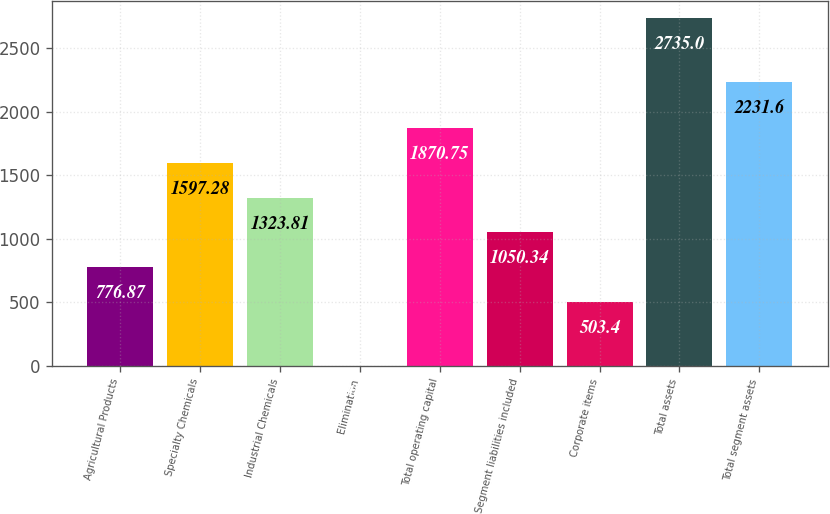Convert chart. <chart><loc_0><loc_0><loc_500><loc_500><bar_chart><fcel>Agricultural Products<fcel>Specialty Chemicals<fcel>Industrial Chemicals<fcel>Elimination<fcel>Total operating capital<fcel>Segment liabilities included<fcel>Corporate items<fcel>Total assets<fcel>Total segment assets<nl><fcel>776.87<fcel>1597.28<fcel>1323.81<fcel>0.3<fcel>1870.75<fcel>1050.34<fcel>503.4<fcel>2735<fcel>2231.6<nl></chart> 